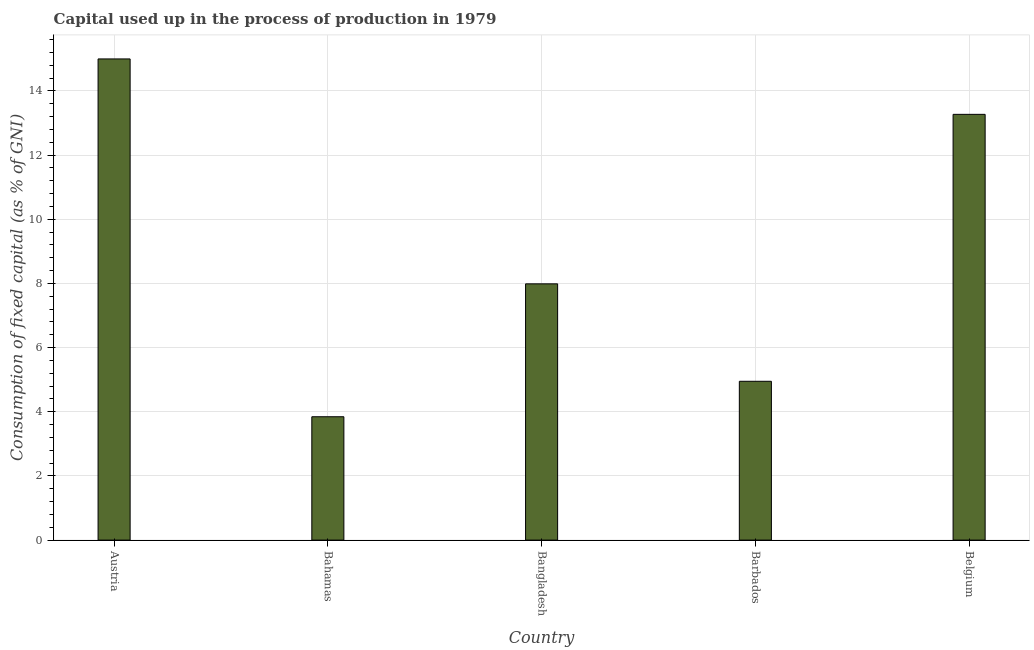Does the graph contain grids?
Offer a very short reply. Yes. What is the title of the graph?
Provide a succinct answer. Capital used up in the process of production in 1979. What is the label or title of the Y-axis?
Offer a terse response. Consumption of fixed capital (as % of GNI). What is the consumption of fixed capital in Barbados?
Provide a succinct answer. 4.95. Across all countries, what is the maximum consumption of fixed capital?
Your answer should be very brief. 15. Across all countries, what is the minimum consumption of fixed capital?
Ensure brevity in your answer.  3.84. In which country was the consumption of fixed capital minimum?
Ensure brevity in your answer.  Bahamas. What is the sum of the consumption of fixed capital?
Provide a succinct answer. 45.04. What is the difference between the consumption of fixed capital in Barbados and Belgium?
Make the answer very short. -8.32. What is the average consumption of fixed capital per country?
Ensure brevity in your answer.  9.01. What is the median consumption of fixed capital?
Keep it short and to the point. 7.99. What is the ratio of the consumption of fixed capital in Bangladesh to that in Belgium?
Offer a terse response. 0.6. Is the consumption of fixed capital in Austria less than that in Bangladesh?
Offer a very short reply. No. Is the difference between the consumption of fixed capital in Bangladesh and Belgium greater than the difference between any two countries?
Your response must be concise. No. What is the difference between the highest and the second highest consumption of fixed capital?
Offer a very short reply. 1.73. What is the difference between the highest and the lowest consumption of fixed capital?
Ensure brevity in your answer.  11.15. Are all the bars in the graph horizontal?
Your answer should be very brief. No. What is the difference between two consecutive major ticks on the Y-axis?
Offer a very short reply. 2. What is the Consumption of fixed capital (as % of GNI) of Austria?
Your answer should be compact. 15. What is the Consumption of fixed capital (as % of GNI) in Bahamas?
Your answer should be very brief. 3.84. What is the Consumption of fixed capital (as % of GNI) in Bangladesh?
Your response must be concise. 7.99. What is the Consumption of fixed capital (as % of GNI) in Barbados?
Provide a succinct answer. 4.95. What is the Consumption of fixed capital (as % of GNI) of Belgium?
Your answer should be compact. 13.27. What is the difference between the Consumption of fixed capital (as % of GNI) in Austria and Bahamas?
Make the answer very short. 11.15. What is the difference between the Consumption of fixed capital (as % of GNI) in Austria and Bangladesh?
Provide a short and direct response. 7.01. What is the difference between the Consumption of fixed capital (as % of GNI) in Austria and Barbados?
Provide a short and direct response. 10.05. What is the difference between the Consumption of fixed capital (as % of GNI) in Austria and Belgium?
Provide a short and direct response. 1.73. What is the difference between the Consumption of fixed capital (as % of GNI) in Bahamas and Bangladesh?
Make the answer very short. -4.14. What is the difference between the Consumption of fixed capital (as % of GNI) in Bahamas and Barbados?
Offer a very short reply. -1.1. What is the difference between the Consumption of fixed capital (as % of GNI) in Bahamas and Belgium?
Give a very brief answer. -9.42. What is the difference between the Consumption of fixed capital (as % of GNI) in Bangladesh and Barbados?
Keep it short and to the point. 3.04. What is the difference between the Consumption of fixed capital (as % of GNI) in Bangladesh and Belgium?
Ensure brevity in your answer.  -5.28. What is the difference between the Consumption of fixed capital (as % of GNI) in Barbados and Belgium?
Your answer should be compact. -8.32. What is the ratio of the Consumption of fixed capital (as % of GNI) in Austria to that in Bahamas?
Make the answer very short. 3.9. What is the ratio of the Consumption of fixed capital (as % of GNI) in Austria to that in Bangladesh?
Give a very brief answer. 1.88. What is the ratio of the Consumption of fixed capital (as % of GNI) in Austria to that in Barbados?
Offer a terse response. 3.03. What is the ratio of the Consumption of fixed capital (as % of GNI) in Austria to that in Belgium?
Ensure brevity in your answer.  1.13. What is the ratio of the Consumption of fixed capital (as % of GNI) in Bahamas to that in Bangladesh?
Offer a terse response. 0.48. What is the ratio of the Consumption of fixed capital (as % of GNI) in Bahamas to that in Barbados?
Make the answer very short. 0.78. What is the ratio of the Consumption of fixed capital (as % of GNI) in Bahamas to that in Belgium?
Provide a short and direct response. 0.29. What is the ratio of the Consumption of fixed capital (as % of GNI) in Bangladesh to that in Barbados?
Offer a terse response. 1.61. What is the ratio of the Consumption of fixed capital (as % of GNI) in Bangladesh to that in Belgium?
Give a very brief answer. 0.6. What is the ratio of the Consumption of fixed capital (as % of GNI) in Barbados to that in Belgium?
Ensure brevity in your answer.  0.37. 